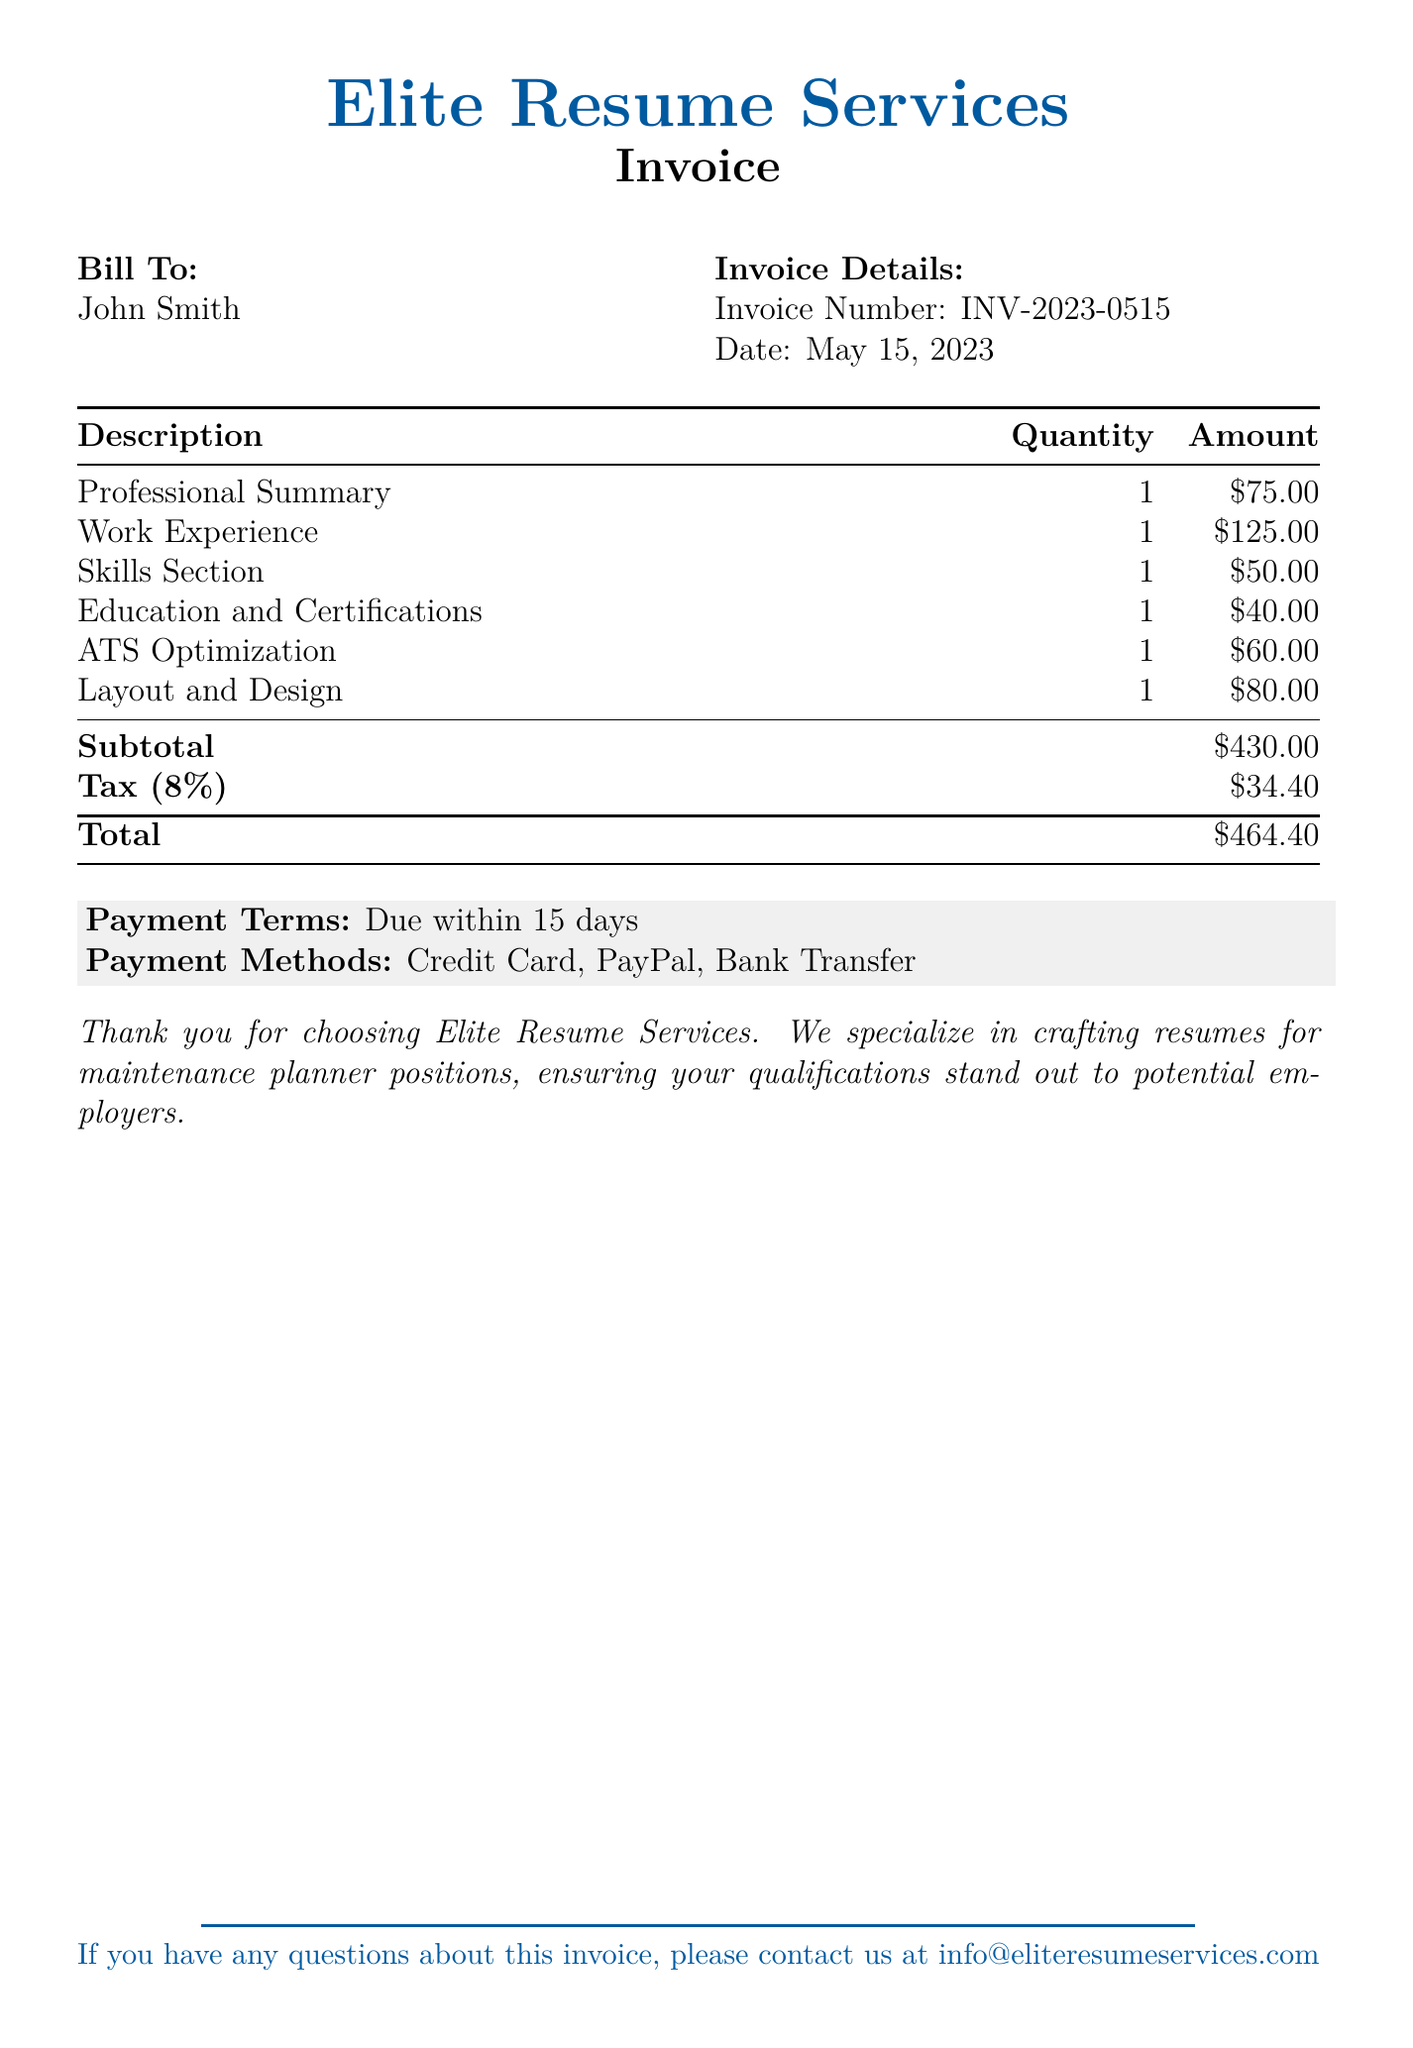What is the invoice number? The invoice number is found in the invoice details section of the document.
Answer: INV-2023-0515 What is the date of the invoice? The date of the invoice is stated in the invoice details section.
Answer: May 15, 2023 What is the total amount due? The total amount due is calculated and listed at the bottom of the charges table.
Answer: $464.40 What is the charge for the Work Experience section? The itemized charge for the Work Experience section is specified in the document.
Answer: $125.00 What percentage is the tax calculated on the subtotal? The tax percentage is indicated in the tax breakdown of the document.
Answer: 8% What is the subtotal before tax? The subtotal is explicitly listed in the charges table before tax is applied.
Answer: $430.00 What are the payment methods mentioned? The payment methods are listed in the payment terms section of the document.
Answer: Credit Card, PayPal, Bank Transfer How many sections were billed in total? The number of sections can be counted from the itemized list of charges in the document.
Answer: 6 What is the payment term duration? The payment term duration is included in the payment terms statement in the document.
Answer: 15 days 